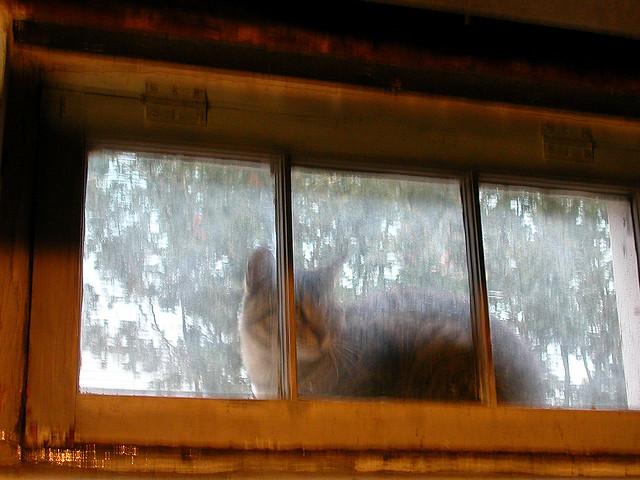What is outside the window?
Short answer required. Cat. Is there glass in the window?
Short answer required. Yes. Is the cat inside?
Keep it brief. No. IS this decorated?
Short answer required. No. Is the cat inside the building?
Write a very short answer. No. What is on the other side of the window?
Be succinct. Cat. Is that a lion?
Give a very brief answer. No. 